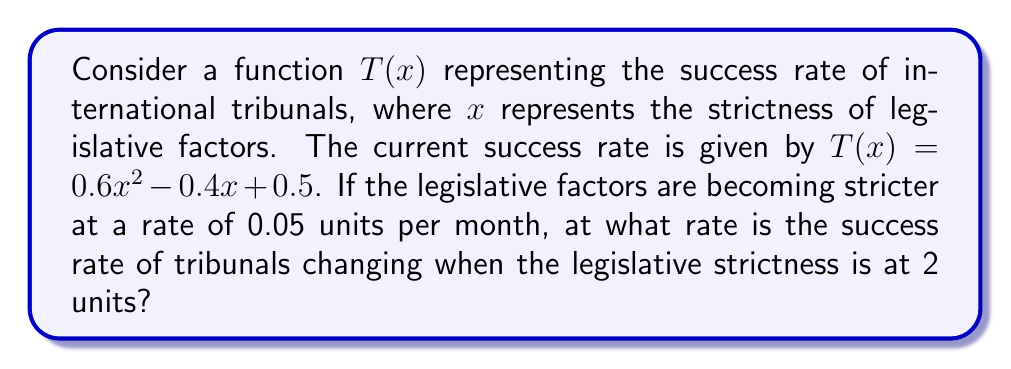Can you solve this math problem? To solve this problem, we need to use the chain rule of derivatives:

1) Let $x$ be a function of time $t$, so $x = f(t)$
2) We're given that $\frac{dx}{dt} = 0.05$ (rate of change of legislative strictness)
3) We need to find $\frac{dT}{dt}$ when $x = 2$

Using the chain rule:

$$\frac{dT}{dt} = \frac{dT}{dx} \cdot \frac{dx}{dt}$$

4) First, let's find $\frac{dT}{dx}$:
   $T(x) = 0.6x^2 - 0.4x + 0.5$
   $\frac{dT}{dx} = 1.2x - 0.4$

5) Now we can substitute this into our chain rule equation:
   $\frac{dT}{dt} = (1.2x - 0.4) \cdot 0.05$

6) When $x = 2$:
   $\frac{dT}{dt} = (1.2(2) - 0.4) \cdot 0.05$
   $\frac{dT}{dt} = (2.4 - 0.4) \cdot 0.05$
   $\frac{dT}{dt} = 2 \cdot 0.05 = 0.1$

Therefore, when the legislative strictness is at 2 units, the success rate of tribunals is changing at a rate of 0.1 units per month.
Answer: 0.1 units per month 